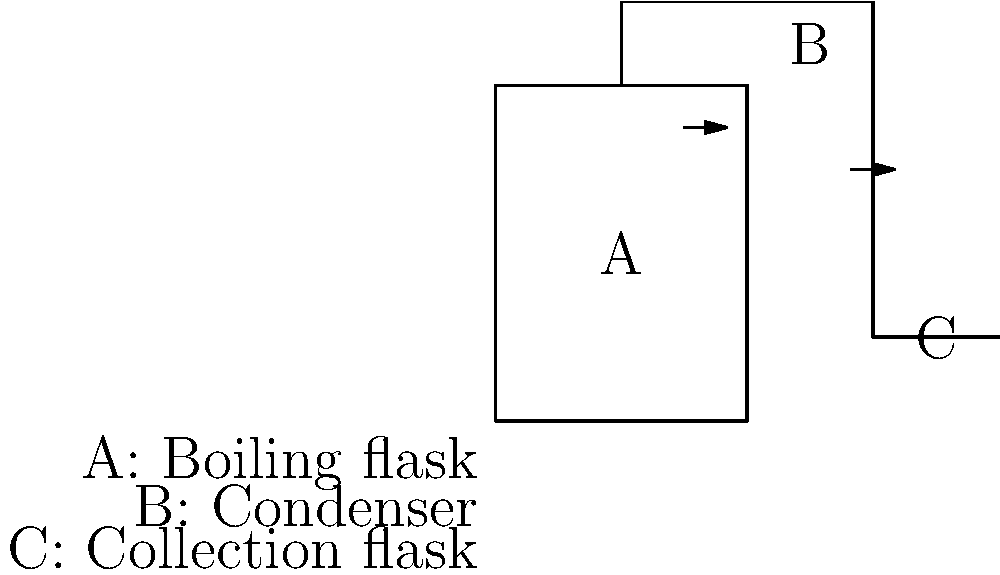In the illustrated steam distillation apparatus, which component is responsible for cooling and condensing the vapor to extract the herbal essence? To understand the steam distillation process and identify the component responsible for cooling and condensing the vapor, let's break down the apparatus:

1. Component A is the boiling flask, where the plant material and water are heated.
2. As the mixture boils, steam and volatile plant compounds rise through the apparatus.
3. Component B is the condenser, which is the key to answering this question.
4. The condenser is typically a tube surrounded by a jacket of cold water.
5. As the hot vapor passes through the condenser, it comes into contact with the cooled surfaces.
6. This rapid cooling causes the vapor to condense back into a liquid form.
7. The condensed liquid, which contains water and the extracted herbal essences, then flows into component C, the collection flask.

The condenser (B) is crucial in this process because it facilitates the phase change from vapor to liquid, allowing for the collection of the herbal essence. Without this cooling and condensing step, the volatile compounds would remain in vapor form and be difficult to collect effectively.
Answer: Condenser (B) 